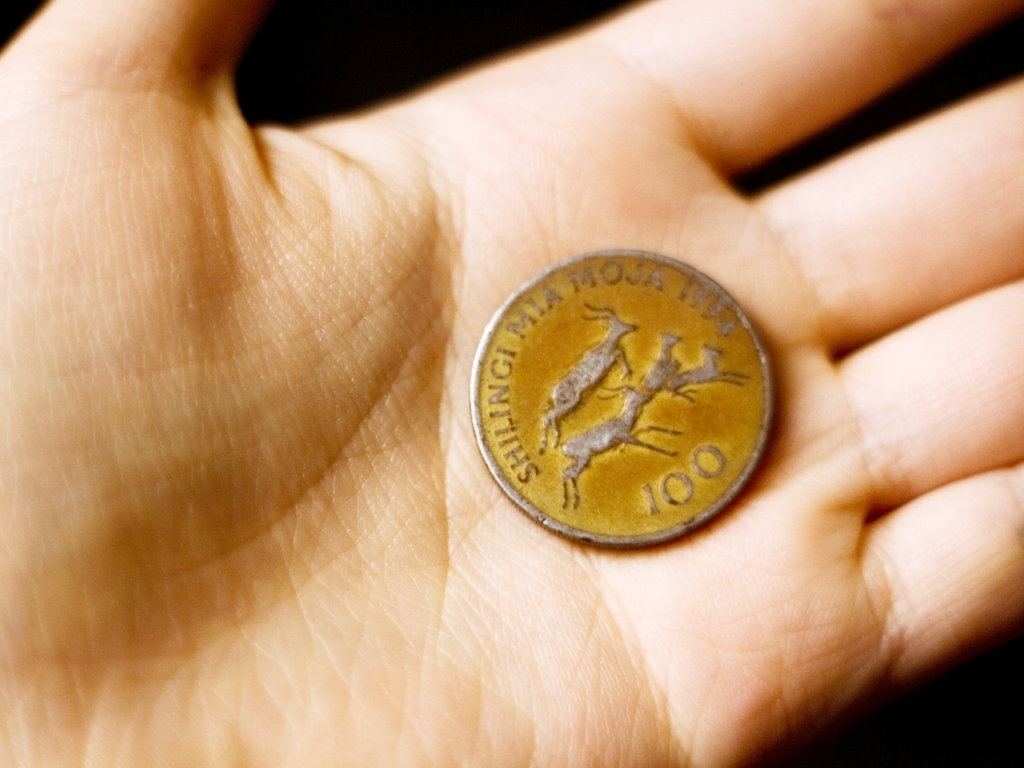What can you tell me about the imagery on this coin? The coin features an embossed design that appears to be a stylized animal, possibly symbolic of the region or nation from which the coin originates. The imagery helps to convey a sense of cultural identity and may also relate to folklore or historical events associated with its place of origin. 